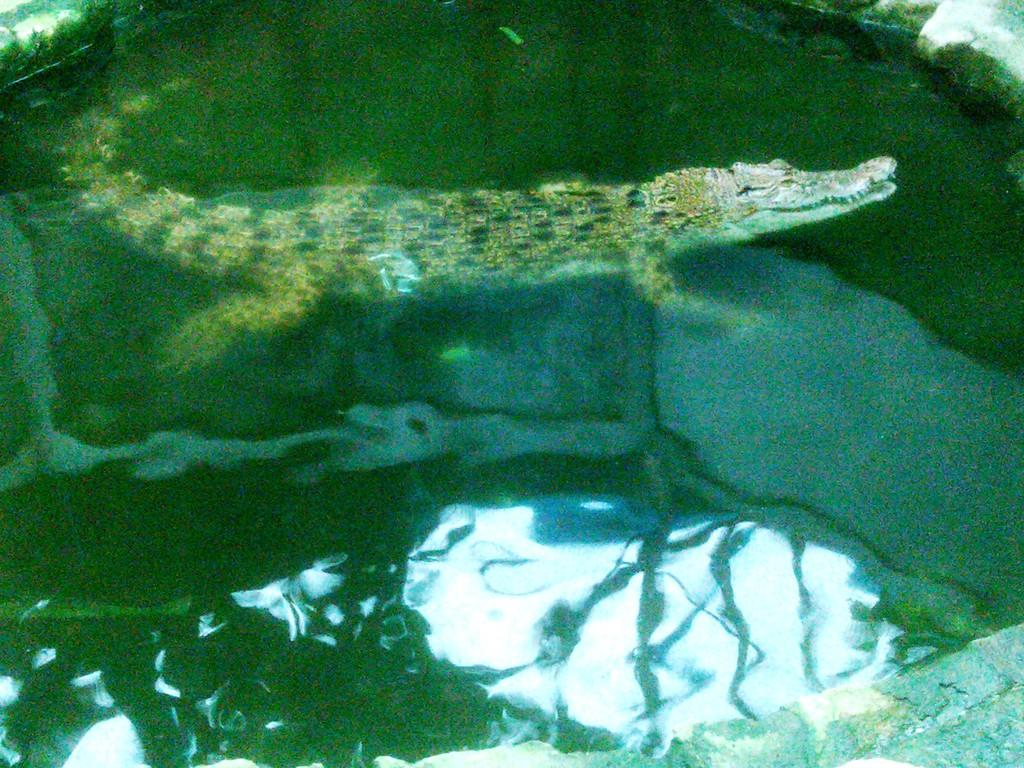What animal can be seen in the water in the image? There is a crocodile in the water in the image. What structure is visible in the top right corner of the image? There is a wall visible in the top right corner of the image. What elements of the natural environment can be seen in the water reflection? Trees and sky are visible in the water reflection. What type of punishment is being given to the crocodile in the image? There is no indication of punishment in the image; it simply shows a crocodile in the water. Whose birthday is being celebrated in the image? There is no indication of a birthday celebration in the image. 